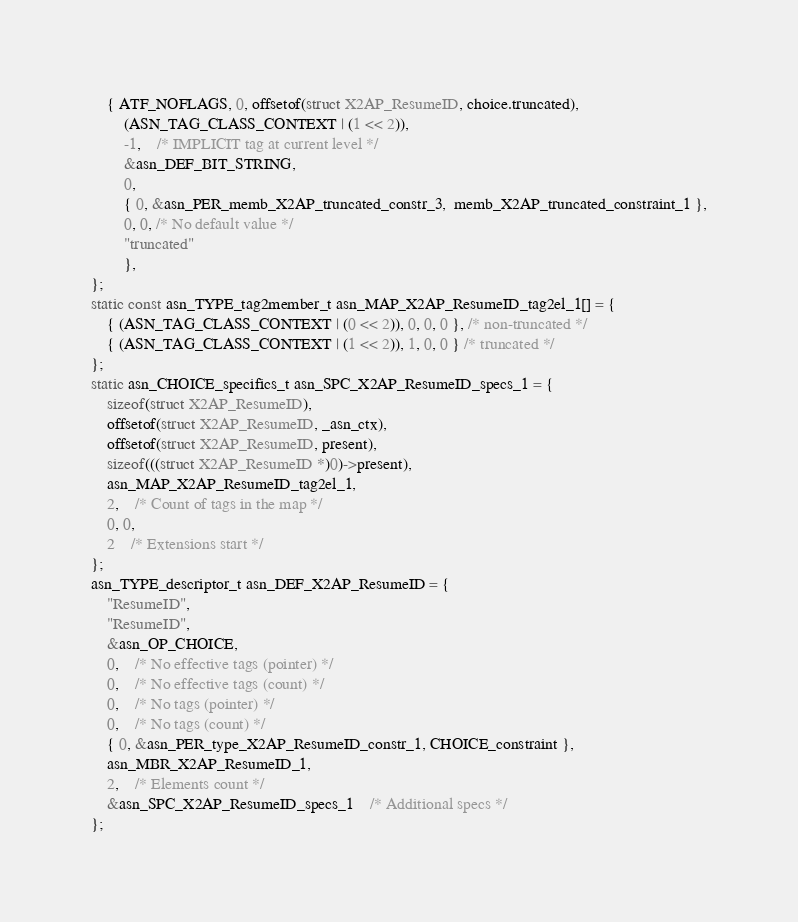Convert code to text. <code><loc_0><loc_0><loc_500><loc_500><_C_>	{ ATF_NOFLAGS, 0, offsetof(struct X2AP_ResumeID, choice.truncated),
		(ASN_TAG_CLASS_CONTEXT | (1 << 2)),
		-1,	/* IMPLICIT tag at current level */
		&asn_DEF_BIT_STRING,
		0,
		{ 0, &asn_PER_memb_X2AP_truncated_constr_3,  memb_X2AP_truncated_constraint_1 },
		0, 0, /* No default value */
		"truncated"
		},
};
static const asn_TYPE_tag2member_t asn_MAP_X2AP_ResumeID_tag2el_1[] = {
    { (ASN_TAG_CLASS_CONTEXT | (0 << 2)), 0, 0, 0 }, /* non-truncated */
    { (ASN_TAG_CLASS_CONTEXT | (1 << 2)), 1, 0, 0 } /* truncated */
};
static asn_CHOICE_specifics_t asn_SPC_X2AP_ResumeID_specs_1 = {
	sizeof(struct X2AP_ResumeID),
	offsetof(struct X2AP_ResumeID, _asn_ctx),
	offsetof(struct X2AP_ResumeID, present),
	sizeof(((struct X2AP_ResumeID *)0)->present),
	asn_MAP_X2AP_ResumeID_tag2el_1,
	2,	/* Count of tags in the map */
	0, 0,
	2	/* Extensions start */
};
asn_TYPE_descriptor_t asn_DEF_X2AP_ResumeID = {
	"ResumeID",
	"ResumeID",
	&asn_OP_CHOICE,
	0,	/* No effective tags (pointer) */
	0,	/* No effective tags (count) */
	0,	/* No tags (pointer) */
	0,	/* No tags (count) */
	{ 0, &asn_PER_type_X2AP_ResumeID_constr_1, CHOICE_constraint },
	asn_MBR_X2AP_ResumeID_1,
	2,	/* Elements count */
	&asn_SPC_X2AP_ResumeID_specs_1	/* Additional specs */
};

</code> 